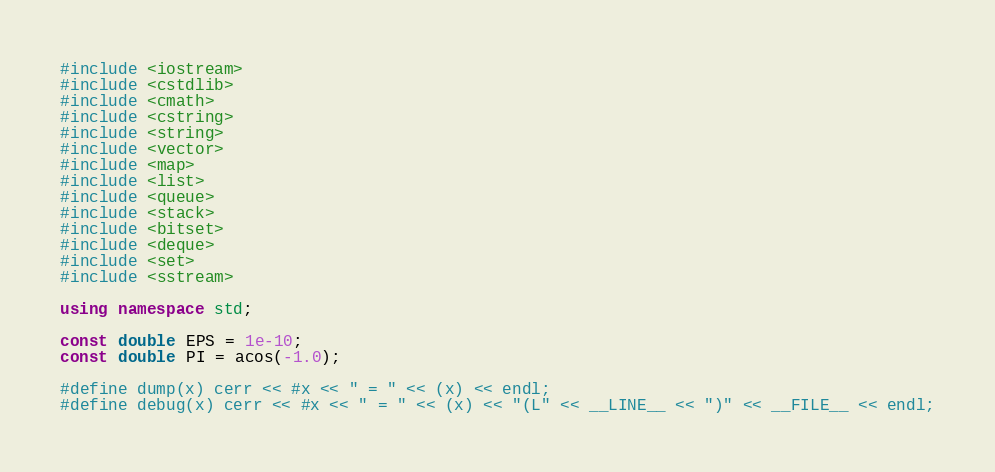Convert code to text. <code><loc_0><loc_0><loc_500><loc_500><_C++_>#include <iostream>
#include <cstdlib>
#include <cmath>
#include <cstring>
#include <string>
#include <vector>
#include <map>
#include <list>
#include <queue>
#include <stack>
#include <bitset>
#include <deque>
#include <set>
#include <sstream>

using namespace std;

const double EPS = 1e-10;
const double PI = acos(-1.0);

#define dump(x) cerr << #x << " = " << (x) << endl;
#define debug(x) cerr << #x << " = " << (x) << "(L" << __LINE__ << ")" << __FILE__ << endl;
</code> 